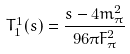<formula> <loc_0><loc_0><loc_500><loc_500>T _ { 1 } ^ { 1 } ( s ) = { \frac { s - 4 m _ { \pi } ^ { 2 } } { 9 6 \pi F _ { \pi } ^ { 2 } } }</formula> 